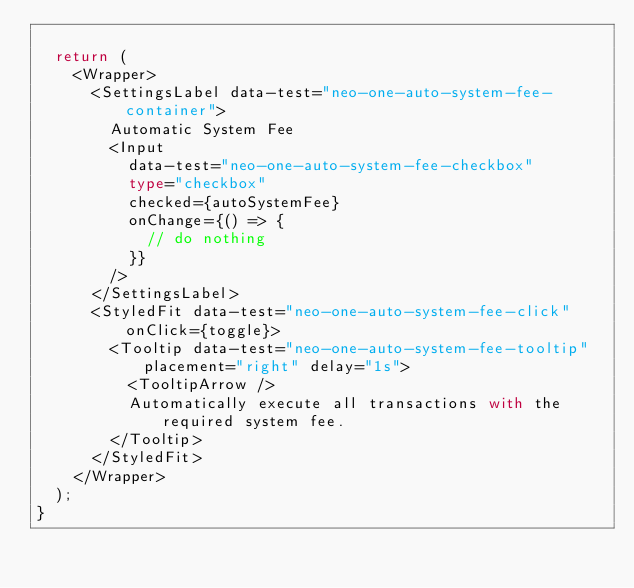Convert code to text. <code><loc_0><loc_0><loc_500><loc_500><_TypeScript_>
  return (
    <Wrapper>
      <SettingsLabel data-test="neo-one-auto-system-fee-container">
        Automatic System Fee
        <Input
          data-test="neo-one-auto-system-fee-checkbox"
          type="checkbox"
          checked={autoSystemFee}
          onChange={() => {
            // do nothing
          }}
        />
      </SettingsLabel>
      <StyledFit data-test="neo-one-auto-system-fee-click" onClick={toggle}>
        <Tooltip data-test="neo-one-auto-system-fee-tooltip" placement="right" delay="1s">
          <TooltipArrow />
          Automatically execute all transactions with the required system fee.
        </Tooltip>
      </StyledFit>
    </Wrapper>
  );
}
</code> 